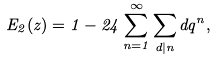<formula> <loc_0><loc_0><loc_500><loc_500>E _ { 2 } ( z ) = 1 - 2 4 \sum _ { n = 1 } ^ { \infty } \sum _ { d | n } d q ^ { n } ,</formula> 